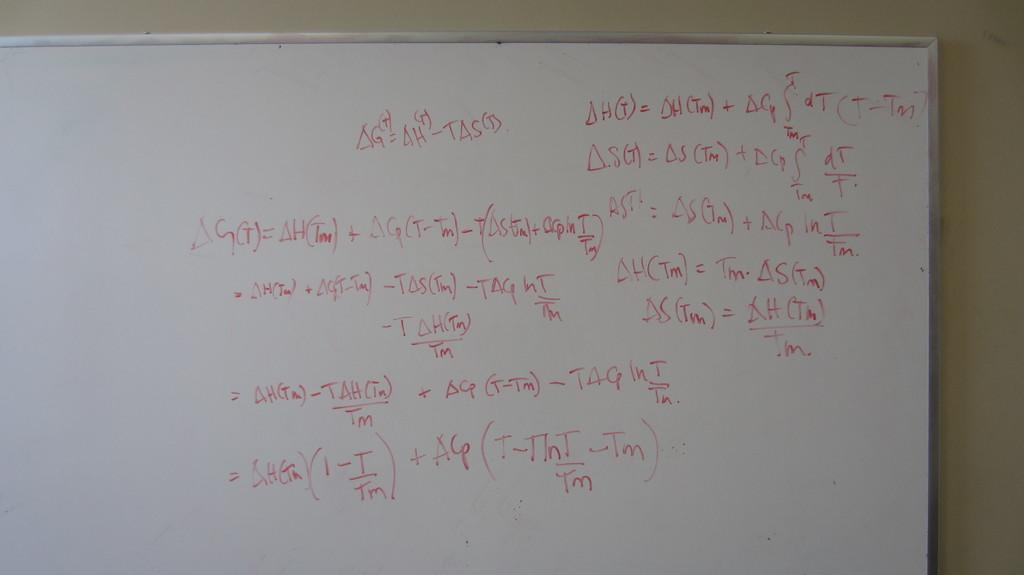Provide a one-sentence caption for the provided image. A white board with various alegebra calculations written on it. 